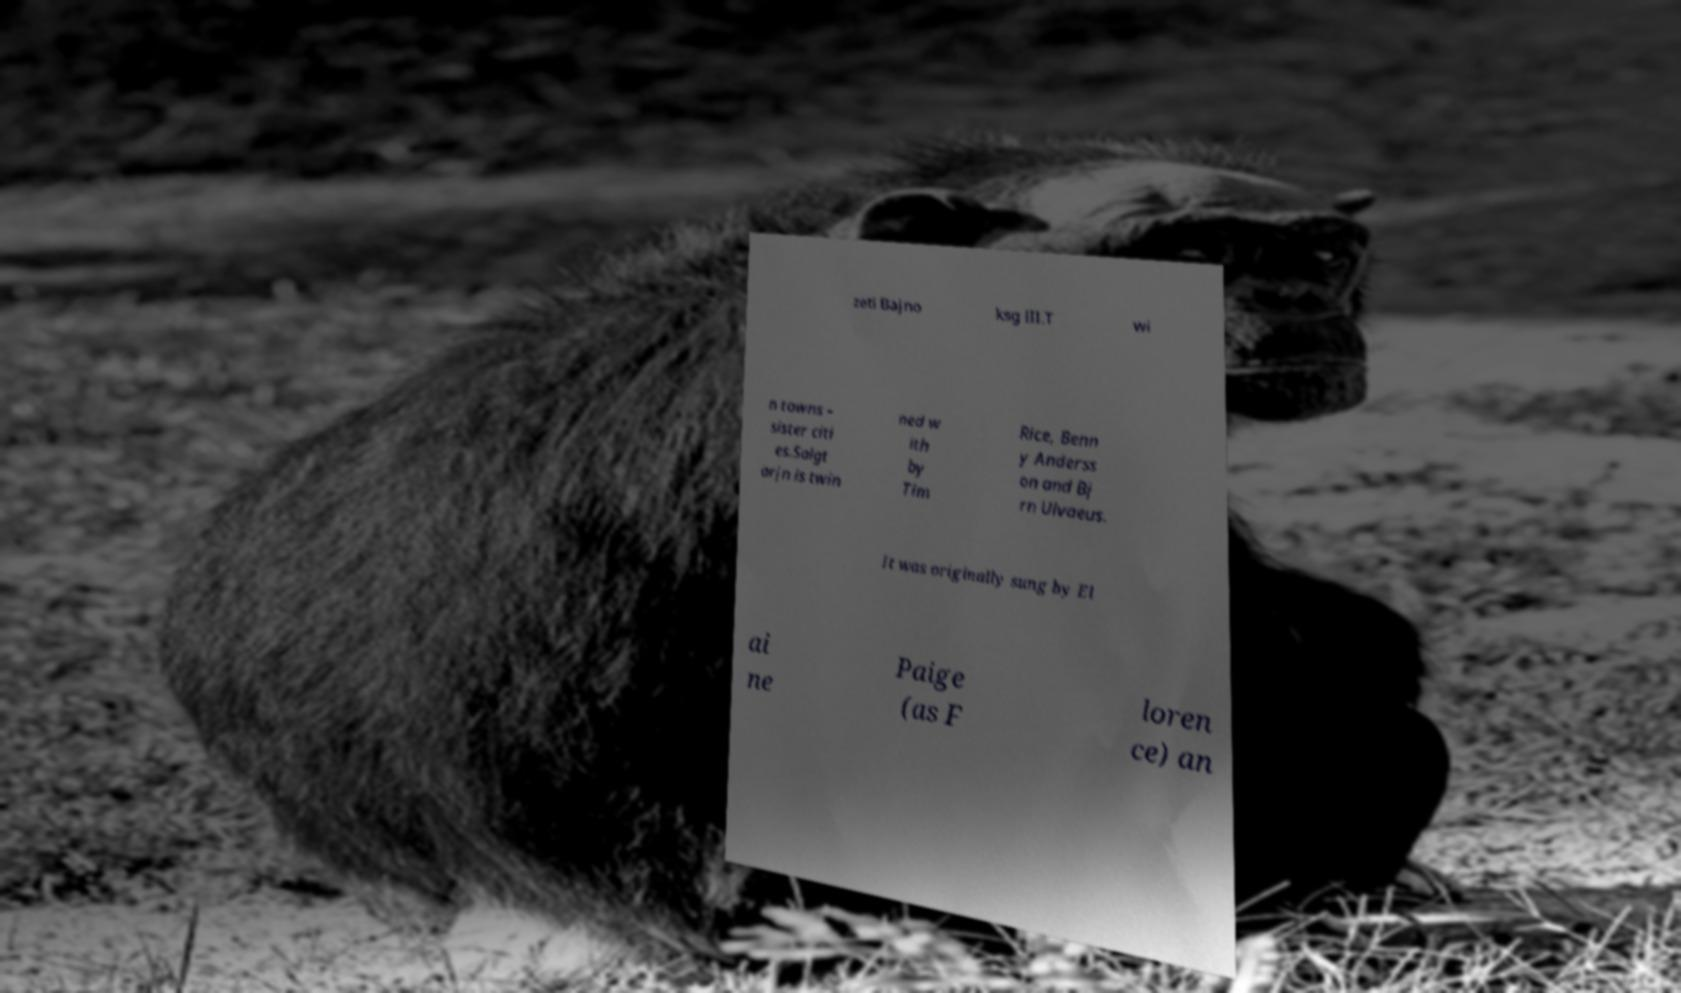For documentation purposes, I need the text within this image transcribed. Could you provide that? zeti Bajno ksg III.T wi n towns – sister citi es.Salgt arjn is twin ned w ith by Tim Rice, Benn y Anderss on and Bj rn Ulvaeus. It was originally sung by El ai ne Paige (as F loren ce) an 